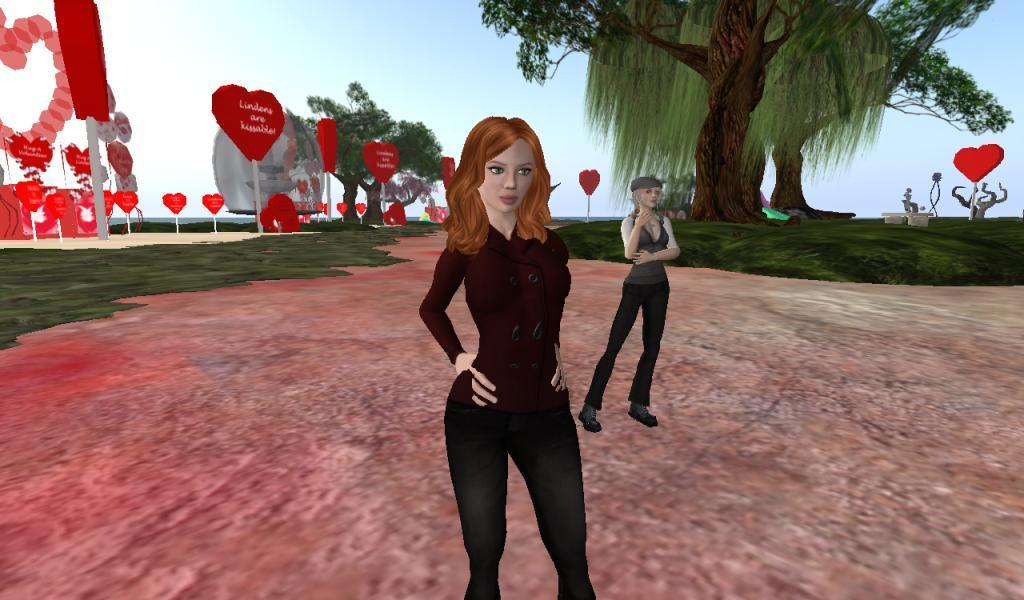What type of image is being described? The image is animated. What can be seen happening in the image? There are two girls standing on a path. What is visible in the background of the image? There are trees and a decoration with balloons in the background. What number is written on the cracker in the image? There is no cracker present in the image, so it is not possible to determine if a number is written on it. 